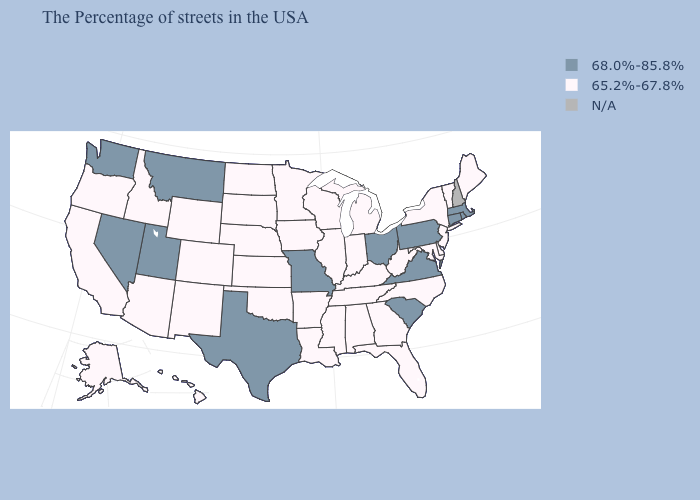Name the states that have a value in the range N/A?
Answer briefly. New Hampshire. How many symbols are there in the legend?
Be succinct. 3. Does Mississippi have the lowest value in the USA?
Concise answer only. Yes. Name the states that have a value in the range N/A?
Give a very brief answer. New Hampshire. What is the value of New Hampshire?
Give a very brief answer. N/A. Among the states that border Vermont , which have the lowest value?
Concise answer only. New York. What is the value of Washington?
Quick response, please. 68.0%-85.8%. What is the value of Hawaii?
Be succinct. 65.2%-67.8%. Does Alabama have the lowest value in the South?
Quick response, please. Yes. Name the states that have a value in the range 65.2%-67.8%?
Short answer required. Maine, Vermont, New York, New Jersey, Delaware, Maryland, North Carolina, West Virginia, Florida, Georgia, Michigan, Kentucky, Indiana, Alabama, Tennessee, Wisconsin, Illinois, Mississippi, Louisiana, Arkansas, Minnesota, Iowa, Kansas, Nebraska, Oklahoma, South Dakota, North Dakota, Wyoming, Colorado, New Mexico, Arizona, Idaho, California, Oregon, Alaska, Hawaii. Among the states that border Wyoming , which have the lowest value?
Keep it brief. Nebraska, South Dakota, Colorado, Idaho. Which states have the lowest value in the West?
Write a very short answer. Wyoming, Colorado, New Mexico, Arizona, Idaho, California, Oregon, Alaska, Hawaii. How many symbols are there in the legend?
Answer briefly. 3. Among the states that border West Virginia , which have the lowest value?
Keep it brief. Maryland, Kentucky. Which states have the lowest value in the USA?
Be succinct. Maine, Vermont, New York, New Jersey, Delaware, Maryland, North Carolina, West Virginia, Florida, Georgia, Michigan, Kentucky, Indiana, Alabama, Tennessee, Wisconsin, Illinois, Mississippi, Louisiana, Arkansas, Minnesota, Iowa, Kansas, Nebraska, Oklahoma, South Dakota, North Dakota, Wyoming, Colorado, New Mexico, Arizona, Idaho, California, Oregon, Alaska, Hawaii. 